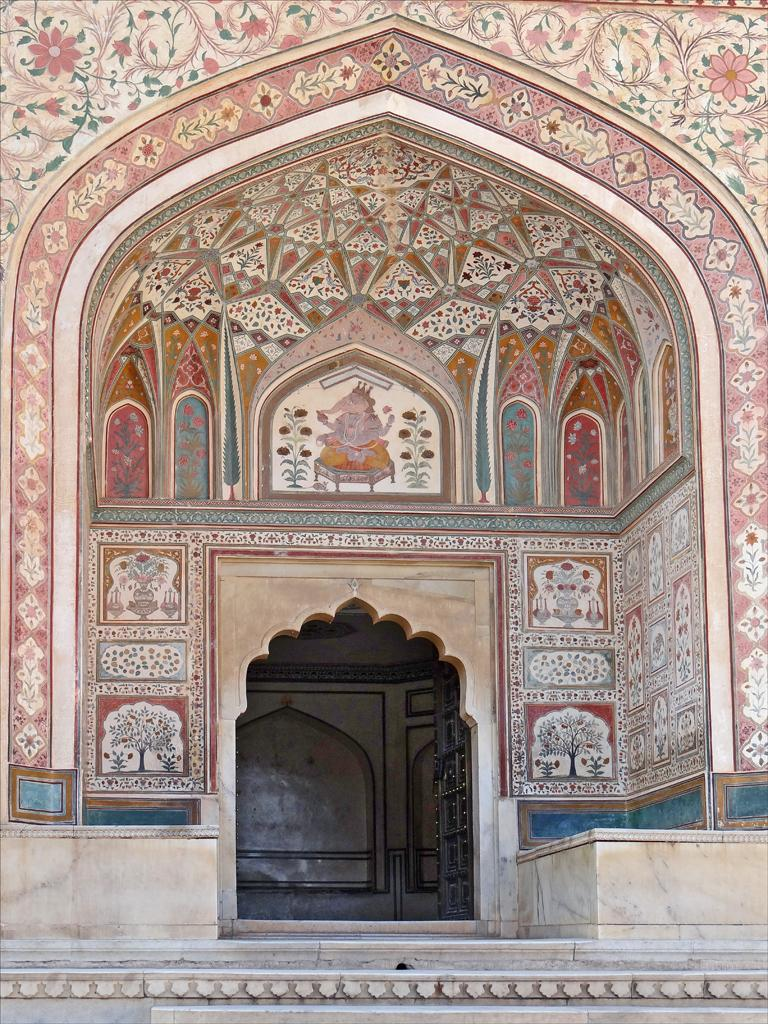What is one of the main objects in the image? There is a door in the image. What can be seen on the walls in the image? There are paintings on the walls in the image. What type of sand can be seen on the floor in the image? There is no sand present on the floor in the image. What disease is depicted in the paintings on the walls? There is no depiction of a disease in the paintings on the walls; the paintings are not described in the provided facts. 